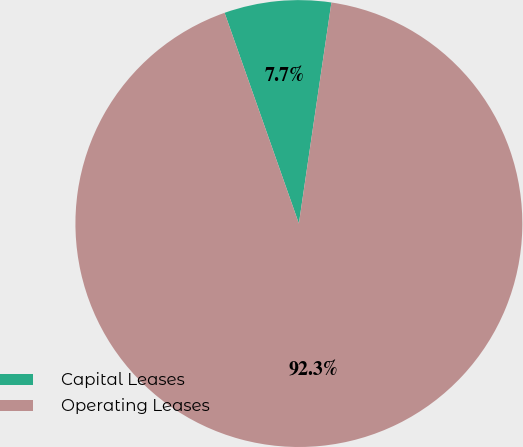Convert chart. <chart><loc_0><loc_0><loc_500><loc_500><pie_chart><fcel>Capital Leases<fcel>Operating Leases<nl><fcel>7.72%<fcel>92.28%<nl></chart> 